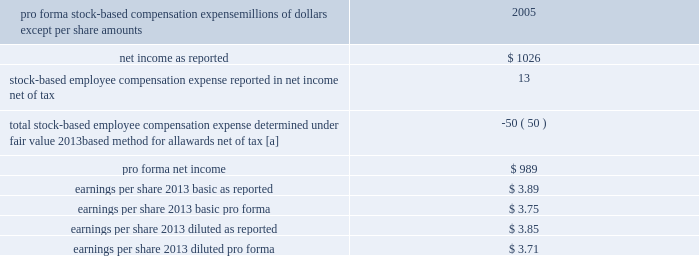The table details the effect on net income and earnings per share had compensation expense for all of our stock-based awards , including stock options , been recorded in the year ended december 31 , 2005 based on the fair value method under fasb statement no .
123 , accounting for stock-based compensation .
Pro forma stock-based compensation expense millions of dollars , except per share amounts 2005 .
[a] stock options for executives granted in 2003 and 2002 included a reload feature .
This reload feature allowed executives to exercise their options using shares of union pacific corporation common stock that they already owned and obtain a new grant of options in the amount of the shares used for exercise plus any shares withheld for tax purposes .
The reload feature of these option grants could only be exercised if the price of our common stock increased at least 20% ( 20 % ) from the price at the time of the reload grant .
During the year ended december 31 , 2005 , reload option grants represented $ 19 million of the pro forma expense noted above .
There were no reload option grants during 2007 and 2006 as stock options exercised after january 1 , 2006 are not eligible for the reload feature .
Earnings per share 2013 basic earnings per share are calculated on the weighted-average number of common shares outstanding during each period .
Diluted earnings per share include shares issuable upon exercise of outstanding stock options and stock-based awards where the conversion of such instruments would be dilutive .
Use of estimates 2013 our consolidated financial statements include estimates and assumptions regarding certain assets , liabilities , revenue , and expenses and the disclosure of certain contingent assets and liabilities .
Actual future results may differ from such estimates .
Income taxes 2013 as required under fasb statement no .
109 , accounting for income taxes , we account for income taxes by recording taxes payable or refundable for the current year and deferred tax assets and liabilities for the expected future tax consequences of events that have been recognized in our financial statements or tax returns .
These expected future tax consequences are measured based on provisions of tax law as currently enacted ; the effects of future changes in tax laws are not anticipated .
Future tax law changes , such as a change in the corporate tax rate , could have a material impact on our financial condition or results of operations .
When appropriate , we record a valuation allowance against deferred tax assets to offset future tax benefits that may not be realized .
In determining whether a valuation allowance is appropriate , we consider whether it is more likely than not that all or some portion of our deferred tax assets will not be realized , based on management 2019s judgments regarding the best available evidence about future events .
When we have claimed tax benefits that may be challenged by a tax authority , these uncertain tax positions are accounted for under fasb interpretation no .
48 , accounting for uncertainty in income taxes , an interpretation of fasb statement no .
109 ( fin 48 ) .
We adopted fin 48 beginning january 1 , 2007 .
Prior to 2007 , income tax contingencies were accounted for under fasb statement no .
5 , accounting for contingencies .
Under fin 48 , we recognize tax benefits only for tax positions that are more likely than not to be sustained upon examination by tax authorities .
The amount recognized is measured as the largest amount of benefit that is greater than 50 percent likely to be realized upon settlement .
A liability for 201cunrecognized tax benefits 201d is .
What was the difference between earnings per share 2013 diluted as reported and earnings per share 2013 diluted pro forma ? 
Computations: (3.71 - 3.85)
Answer: -0.14. The table details the effect on net income and earnings per share had compensation expense for all of our stock-based awards , including stock options , been recorded in the year ended december 31 , 2005 based on the fair value method under fasb statement no .
123 , accounting for stock-based compensation .
Pro forma stock-based compensation expense millions of dollars , except per share amounts 2005 .
[a] stock options for executives granted in 2003 and 2002 included a reload feature .
This reload feature allowed executives to exercise their options using shares of union pacific corporation common stock that they already owned and obtain a new grant of options in the amount of the shares used for exercise plus any shares withheld for tax purposes .
The reload feature of these option grants could only be exercised if the price of our common stock increased at least 20% ( 20 % ) from the price at the time of the reload grant .
During the year ended december 31 , 2005 , reload option grants represented $ 19 million of the pro forma expense noted above .
There were no reload option grants during 2007 and 2006 as stock options exercised after january 1 , 2006 are not eligible for the reload feature .
Earnings per share 2013 basic earnings per share are calculated on the weighted-average number of common shares outstanding during each period .
Diluted earnings per share include shares issuable upon exercise of outstanding stock options and stock-based awards where the conversion of such instruments would be dilutive .
Use of estimates 2013 our consolidated financial statements include estimates and assumptions regarding certain assets , liabilities , revenue , and expenses and the disclosure of certain contingent assets and liabilities .
Actual future results may differ from such estimates .
Income taxes 2013 as required under fasb statement no .
109 , accounting for income taxes , we account for income taxes by recording taxes payable or refundable for the current year and deferred tax assets and liabilities for the expected future tax consequences of events that have been recognized in our financial statements or tax returns .
These expected future tax consequences are measured based on provisions of tax law as currently enacted ; the effects of future changes in tax laws are not anticipated .
Future tax law changes , such as a change in the corporate tax rate , could have a material impact on our financial condition or results of operations .
When appropriate , we record a valuation allowance against deferred tax assets to offset future tax benefits that may not be realized .
In determining whether a valuation allowance is appropriate , we consider whether it is more likely than not that all or some portion of our deferred tax assets will not be realized , based on management 2019s judgments regarding the best available evidence about future events .
When we have claimed tax benefits that may be challenged by a tax authority , these uncertain tax positions are accounted for under fasb interpretation no .
48 , accounting for uncertainty in income taxes , an interpretation of fasb statement no .
109 ( fin 48 ) .
We adopted fin 48 beginning january 1 , 2007 .
Prior to 2007 , income tax contingencies were accounted for under fasb statement no .
5 , accounting for contingencies .
Under fin 48 , we recognize tax benefits only for tax positions that are more likely than not to be sustained upon examination by tax authorities .
The amount recognized is measured as the largest amount of benefit that is greater than 50 percent likely to be realized upon settlement .
A liability for 201cunrecognized tax benefits 201d is .
What was the percentage difference between earnings per share 2013 diluted as reported and earnings per share 2013 diluted pro forma ? 
Computations: ((3.71 - 3.85) / 3.85)
Answer: -0.03636. 